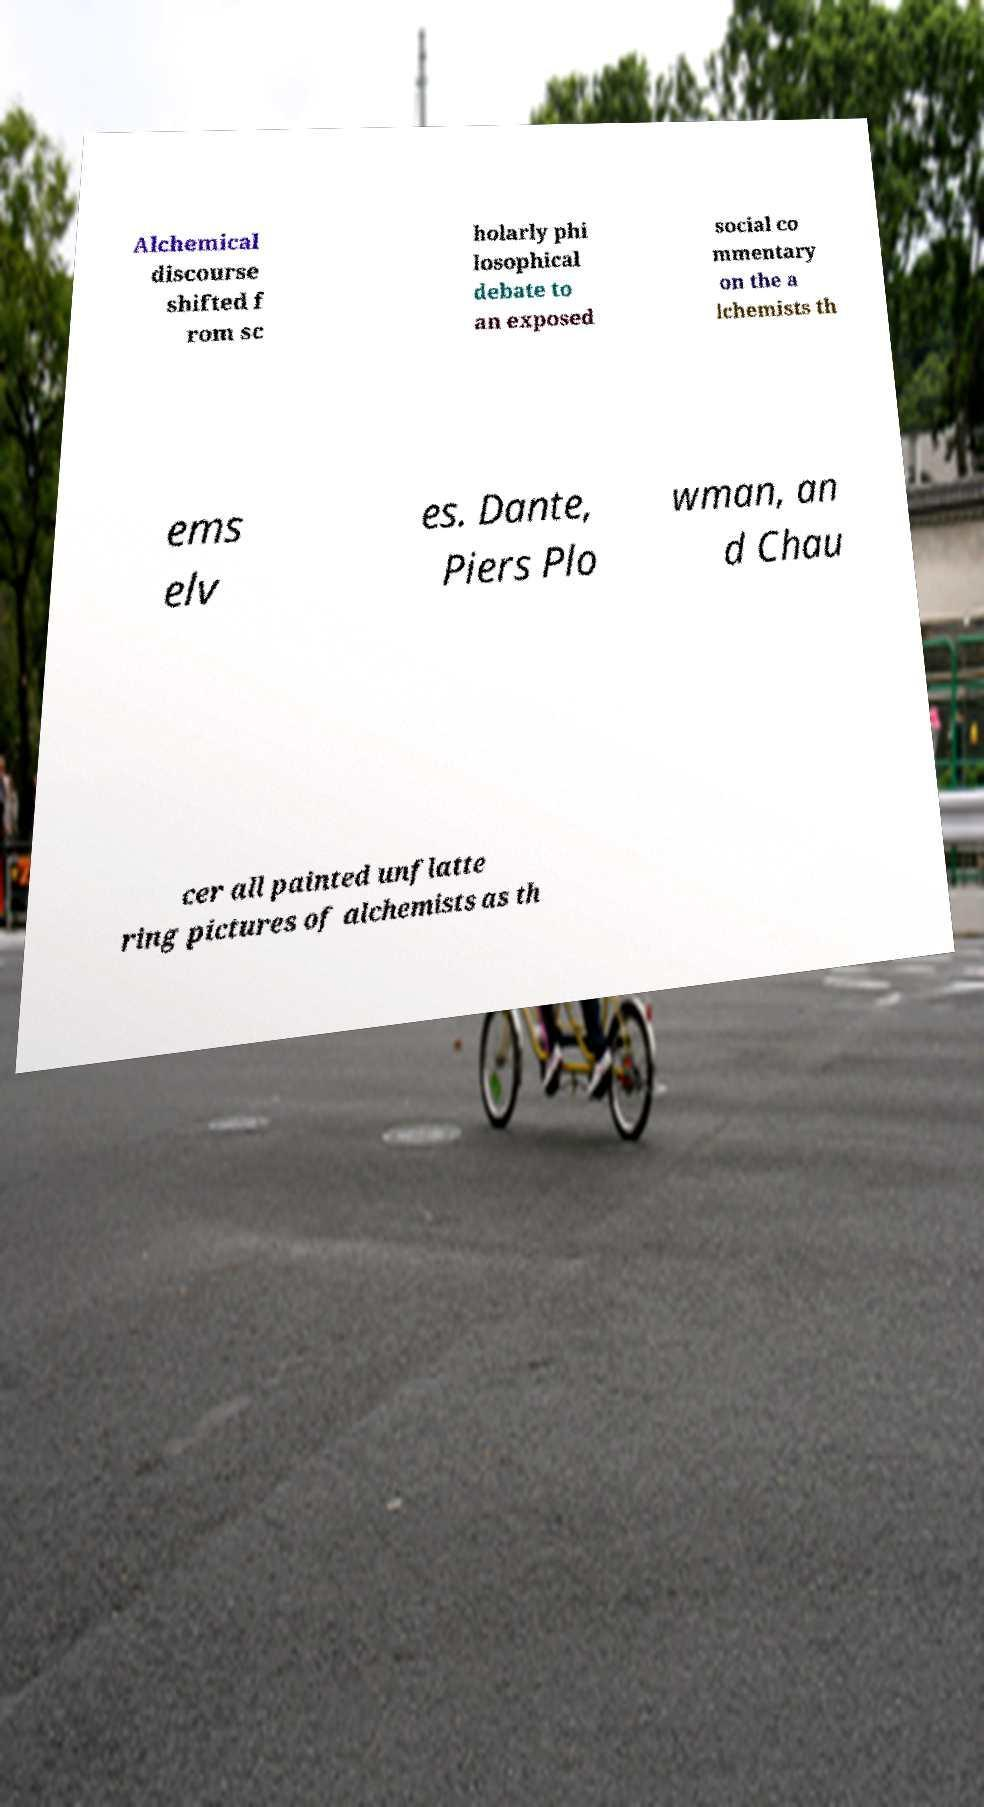Could you assist in decoding the text presented in this image and type it out clearly? Alchemical discourse shifted f rom sc holarly phi losophical debate to an exposed social co mmentary on the a lchemists th ems elv es. Dante, Piers Plo wman, an d Chau cer all painted unflatte ring pictures of alchemists as th 